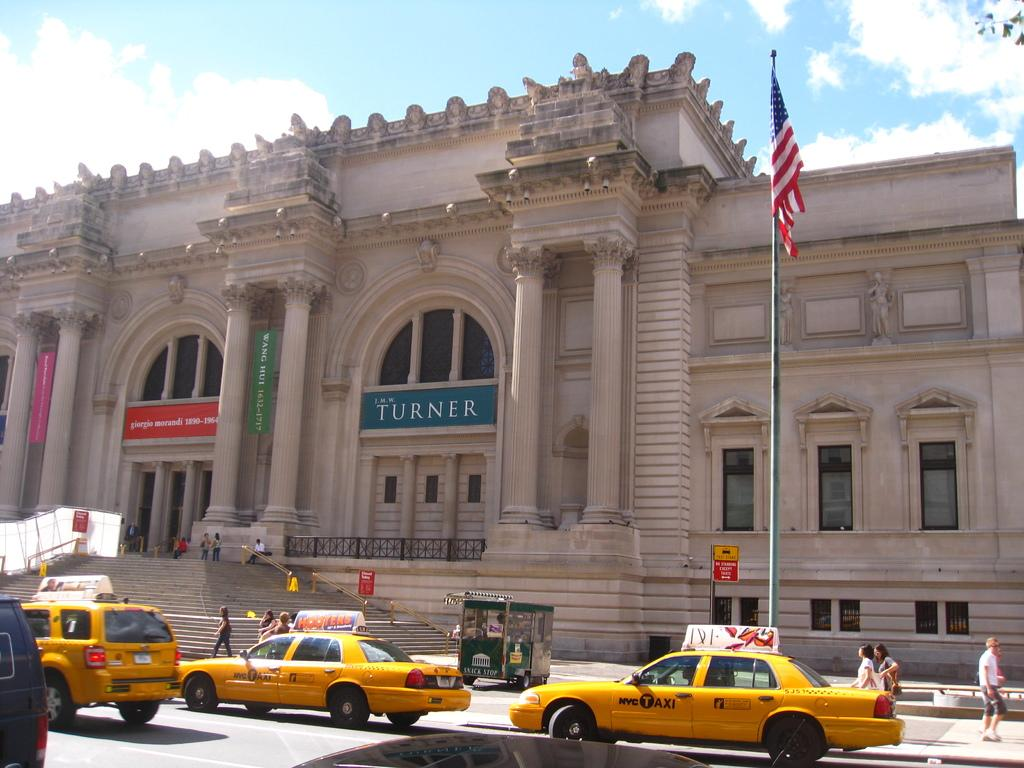<image>
Present a compact description of the photo's key features. a building that has the word Turner on it 